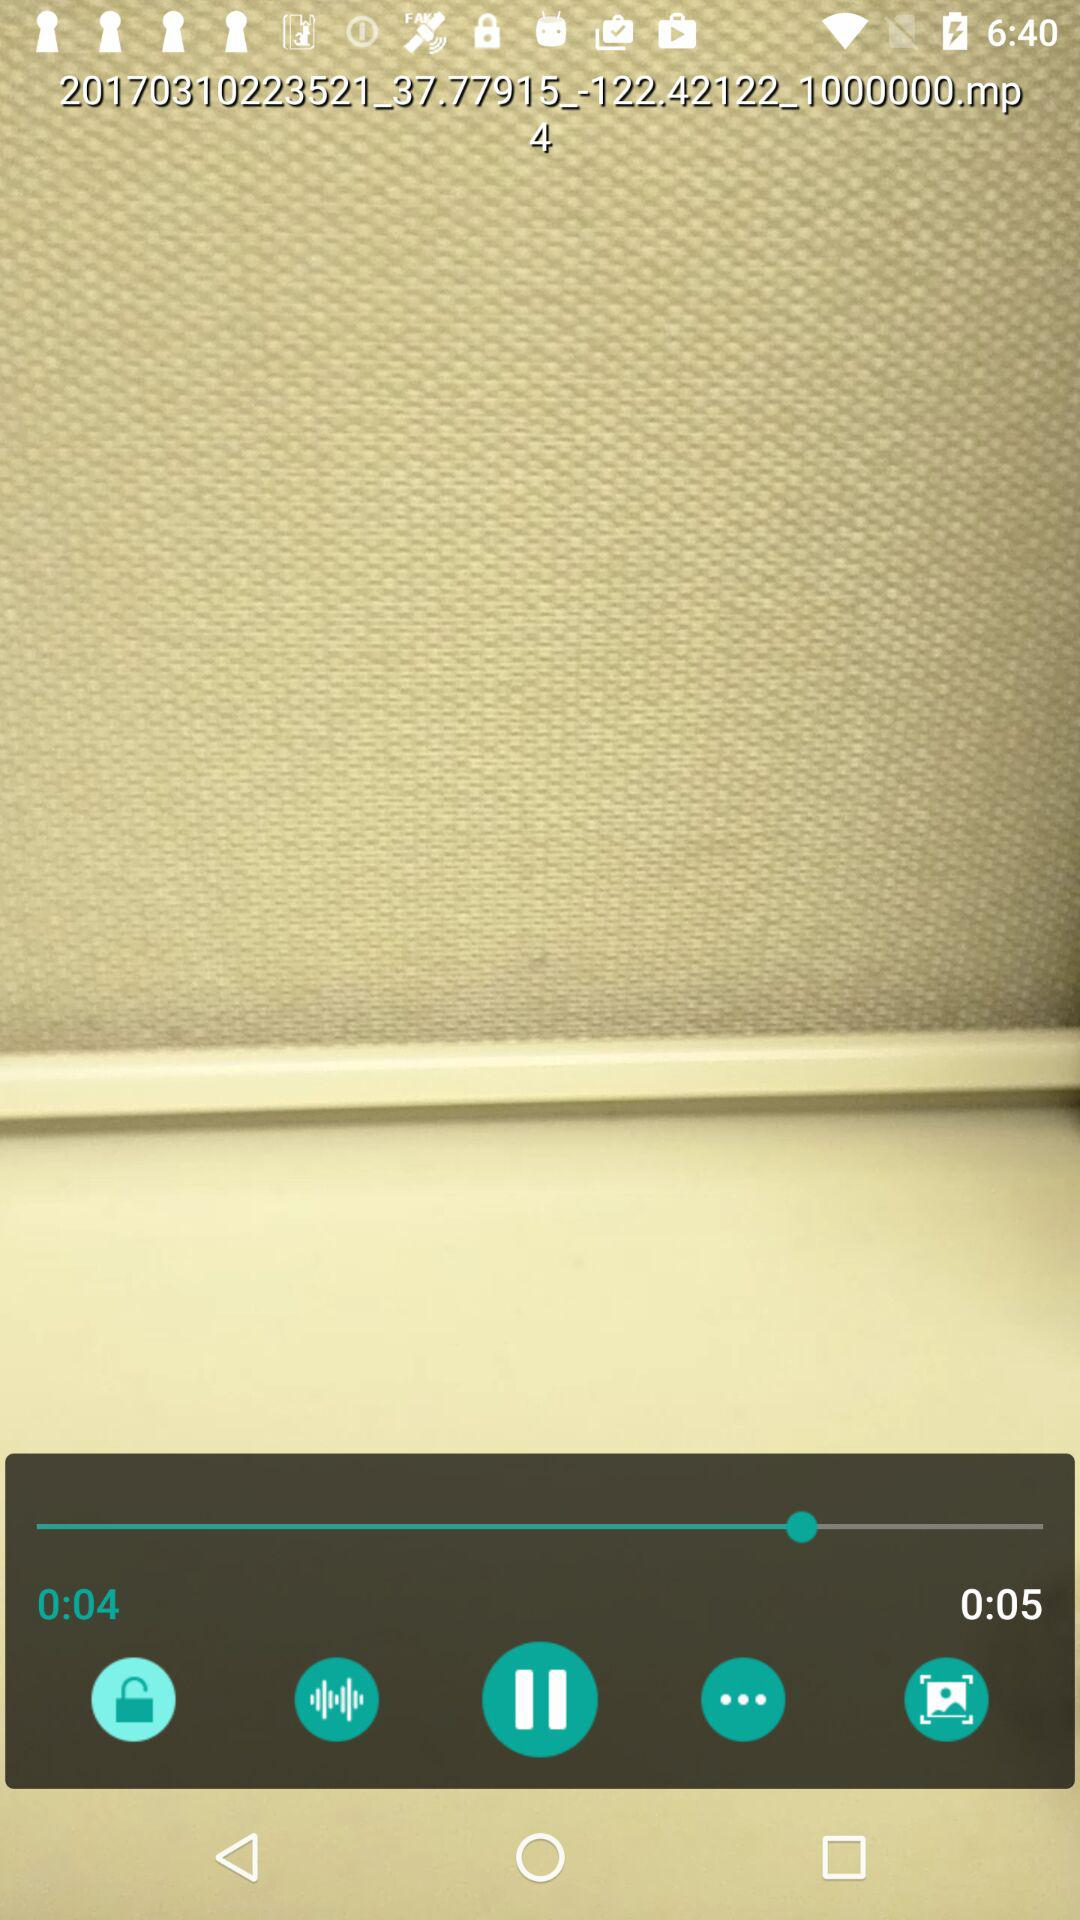How many more seconds is the video duration than the timestamp?
Answer the question using a single word or phrase. 1 